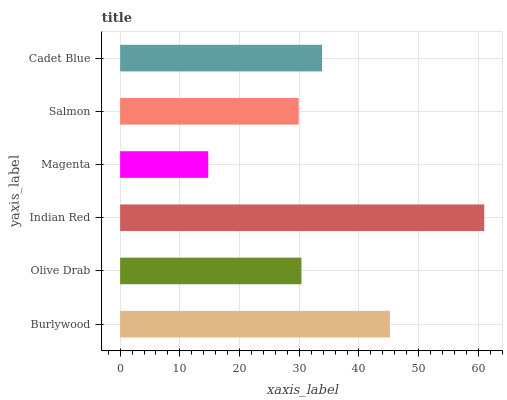Is Magenta the minimum?
Answer yes or no. Yes. Is Indian Red the maximum?
Answer yes or no. Yes. Is Olive Drab the minimum?
Answer yes or no. No. Is Olive Drab the maximum?
Answer yes or no. No. Is Burlywood greater than Olive Drab?
Answer yes or no. Yes. Is Olive Drab less than Burlywood?
Answer yes or no. Yes. Is Olive Drab greater than Burlywood?
Answer yes or no. No. Is Burlywood less than Olive Drab?
Answer yes or no. No. Is Cadet Blue the high median?
Answer yes or no. Yes. Is Olive Drab the low median?
Answer yes or no. Yes. Is Burlywood the high median?
Answer yes or no. No. Is Salmon the low median?
Answer yes or no. No. 